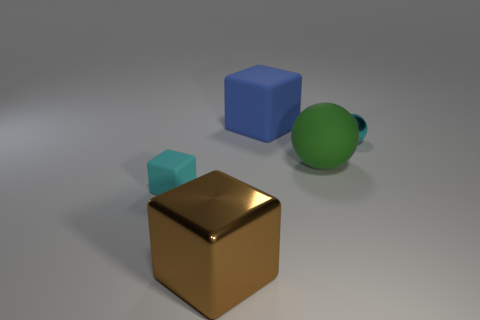The block in front of the tiny rubber cube on the left side of the large object in front of the cyan matte cube is made of what material?
Your answer should be very brief. Metal. Does the shiny object behind the small cyan matte thing have the same size as the metal object on the left side of the large blue thing?
Your answer should be very brief. No. How many other objects are there of the same material as the tiny block?
Ensure brevity in your answer.  2. What number of matte objects are large purple blocks or tiny spheres?
Offer a terse response. 0. Is the number of big green objects less than the number of large yellow metallic things?
Your answer should be very brief. No. There is a blue rubber object; does it have the same size as the shiny thing that is behind the small cyan rubber object?
Ensure brevity in your answer.  No. Is there any other thing that has the same shape as the green thing?
Give a very brief answer. Yes. What size is the rubber ball?
Your answer should be very brief. Large. Is the number of large green matte things to the left of the large green sphere less than the number of tiny metal spheres?
Offer a very short reply. Yes. Do the metal sphere and the blue cube have the same size?
Your response must be concise. No. 